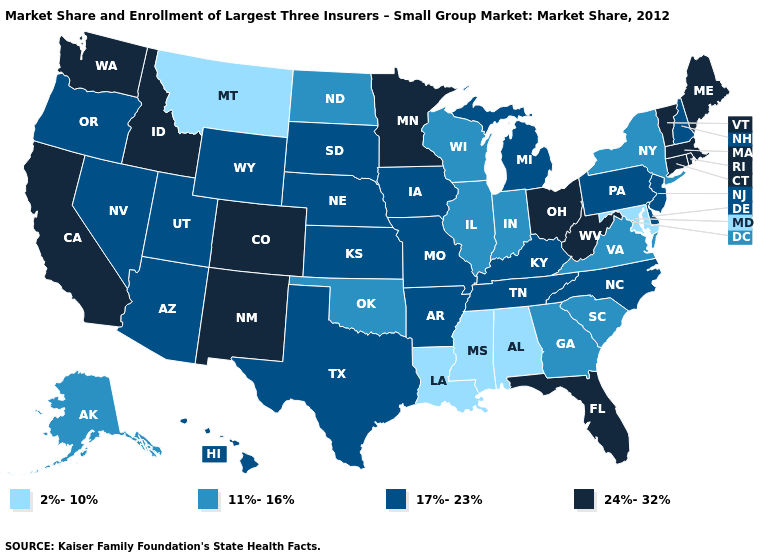What is the highest value in states that border Oregon?
Write a very short answer. 24%-32%. Name the states that have a value in the range 24%-32%?
Quick response, please. California, Colorado, Connecticut, Florida, Idaho, Maine, Massachusetts, Minnesota, New Mexico, Ohio, Rhode Island, Vermont, Washington, West Virginia. Is the legend a continuous bar?
Keep it brief. No. What is the value of Pennsylvania?
Write a very short answer. 17%-23%. Does Arizona have the lowest value in the USA?
Short answer required. No. Name the states that have a value in the range 17%-23%?
Answer briefly. Arizona, Arkansas, Delaware, Hawaii, Iowa, Kansas, Kentucky, Michigan, Missouri, Nebraska, Nevada, New Hampshire, New Jersey, North Carolina, Oregon, Pennsylvania, South Dakota, Tennessee, Texas, Utah, Wyoming. Which states have the lowest value in the South?
Quick response, please. Alabama, Louisiana, Maryland, Mississippi. What is the value of Kentucky?
Quick response, please. 17%-23%. Does Alabama have the lowest value in the USA?
Be succinct. Yes. What is the value of Texas?
Concise answer only. 17%-23%. What is the highest value in the West ?
Keep it brief. 24%-32%. What is the value of Hawaii?
Be succinct. 17%-23%. Name the states that have a value in the range 2%-10%?
Give a very brief answer. Alabama, Louisiana, Maryland, Mississippi, Montana. What is the value of New Hampshire?
Keep it brief. 17%-23%. What is the value of Arkansas?
Write a very short answer. 17%-23%. 